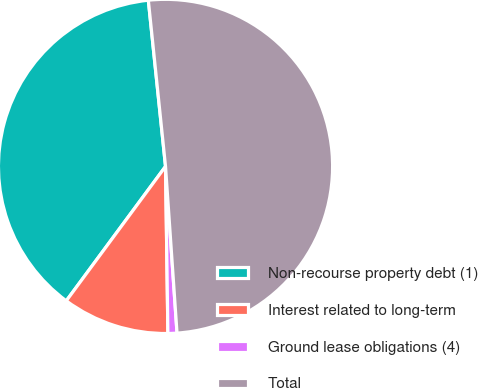<chart> <loc_0><loc_0><loc_500><loc_500><pie_chart><fcel>Non-recourse property debt (1)<fcel>Interest related to long-term<fcel>Ground lease obligations (4)<fcel>Total<nl><fcel>38.24%<fcel>10.35%<fcel>0.87%<fcel>50.55%<nl></chart> 